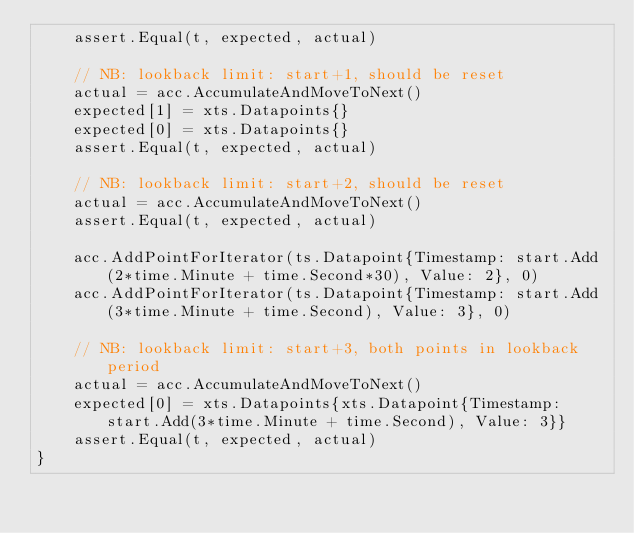<code> <loc_0><loc_0><loc_500><loc_500><_Go_>	assert.Equal(t, expected, actual)

	// NB: lookback limit: start+1, should be reset
	actual = acc.AccumulateAndMoveToNext()
	expected[1] = xts.Datapoints{}
	expected[0] = xts.Datapoints{}
	assert.Equal(t, expected, actual)

	// NB: lookback limit: start+2, should be reset
	actual = acc.AccumulateAndMoveToNext()
	assert.Equal(t, expected, actual)

	acc.AddPointForIterator(ts.Datapoint{Timestamp: start.Add(2*time.Minute + time.Second*30), Value: 2}, 0)
	acc.AddPointForIterator(ts.Datapoint{Timestamp: start.Add(3*time.Minute + time.Second), Value: 3}, 0)

	// NB: lookback limit: start+3, both points in lookback period
	actual = acc.AccumulateAndMoveToNext()
	expected[0] = xts.Datapoints{xts.Datapoint{Timestamp: start.Add(3*time.Minute + time.Second), Value: 3}}
	assert.Equal(t, expected, actual)
}
</code> 